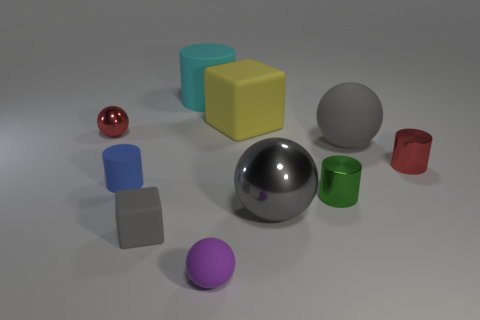Subtract all cylinders. How many objects are left? 6 Subtract all gray spheres. Subtract all small gray things. How many objects are left? 7 Add 4 matte blocks. How many matte blocks are left? 6 Add 5 blue rubber cylinders. How many blue rubber cylinders exist? 6 Subtract 1 yellow cubes. How many objects are left? 9 